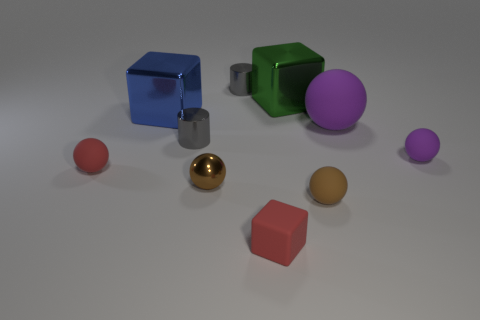Subtract all large purple rubber balls. How many balls are left? 4 Subtract all red spheres. How many spheres are left? 4 Subtract all blue spheres. Subtract all cyan blocks. How many spheres are left? 5 Subtract all cylinders. How many objects are left? 8 Add 8 purple objects. How many purple objects are left? 10 Add 8 purple rubber cylinders. How many purple rubber cylinders exist? 8 Subtract 0 cyan balls. How many objects are left? 10 Subtract all small red shiny things. Subtract all big green metal cubes. How many objects are left? 9 